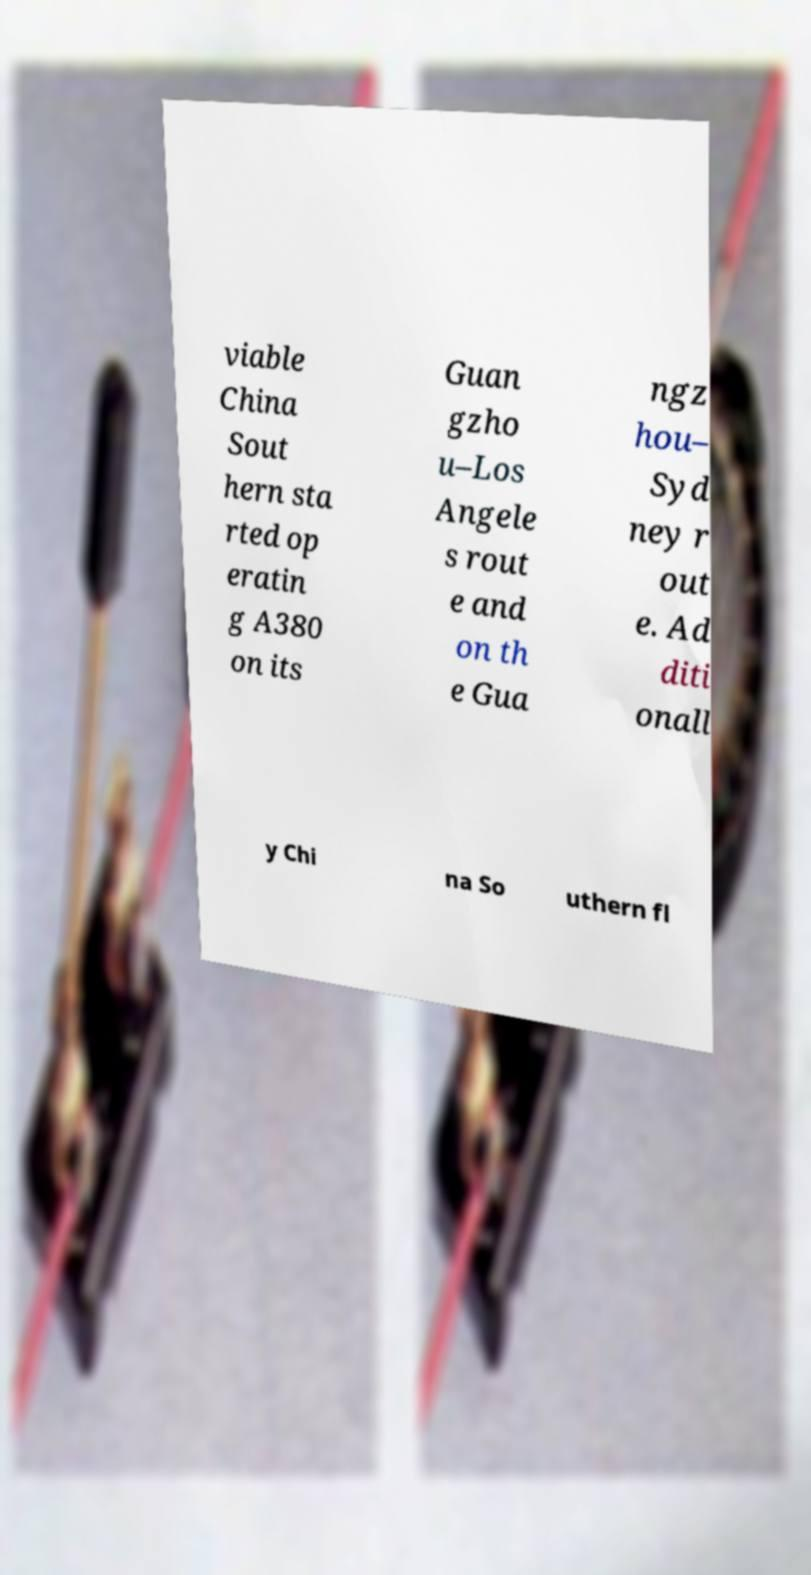Can you accurately transcribe the text from the provided image for me? viable China Sout hern sta rted op eratin g A380 on its Guan gzho u–Los Angele s rout e and on th e Gua ngz hou– Syd ney r out e. Ad diti onall y Chi na So uthern fl 